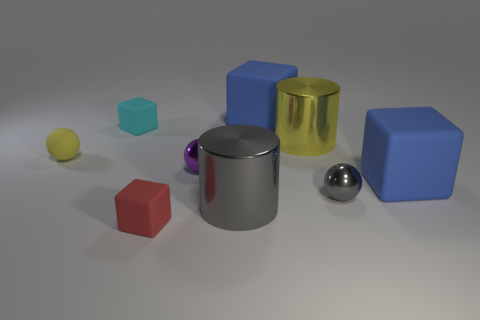Subtract all blue spheres. How many blue cubes are left? 2 Subtract 2 blocks. How many blocks are left? 2 Subtract all cyan blocks. How many blocks are left? 3 Subtract all tiny cyan blocks. How many blocks are left? 3 Subtract all yellow cubes. Subtract all gray spheres. How many cubes are left? 4 Subtract all cubes. How many objects are left? 5 Subtract 1 gray balls. How many objects are left? 8 Subtract all brown shiny cubes. Subtract all small cyan matte objects. How many objects are left? 8 Add 6 tiny yellow matte things. How many tiny yellow matte things are left? 7 Add 5 big objects. How many big objects exist? 9 